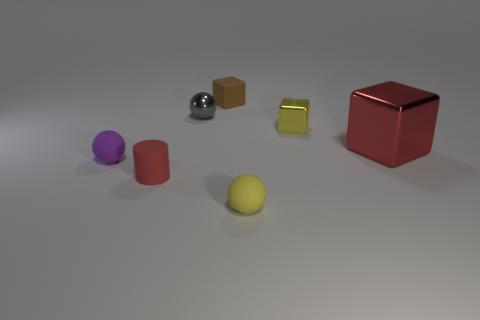Subtract all yellow matte balls. How many balls are left? 2 Add 1 small yellow cubes. How many objects exist? 8 Subtract all yellow blocks. How many blocks are left? 2 Subtract all cylinders. How many objects are left? 6 Subtract 0 brown cylinders. How many objects are left? 7 Subtract 1 cubes. How many cubes are left? 2 Subtract all purple cubes. Subtract all brown cylinders. How many cubes are left? 3 Subtract all big purple shiny cylinders. Subtract all tiny red matte cylinders. How many objects are left? 6 Add 3 small red matte objects. How many small red matte objects are left? 4 Add 6 large things. How many large things exist? 7 